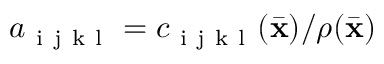Convert formula to latex. <formula><loc_0><loc_0><loc_500><loc_500>a _ { i j k l } = c _ { i j k l } ( \bar { x } ) / \rho ( \bar { x } )</formula> 